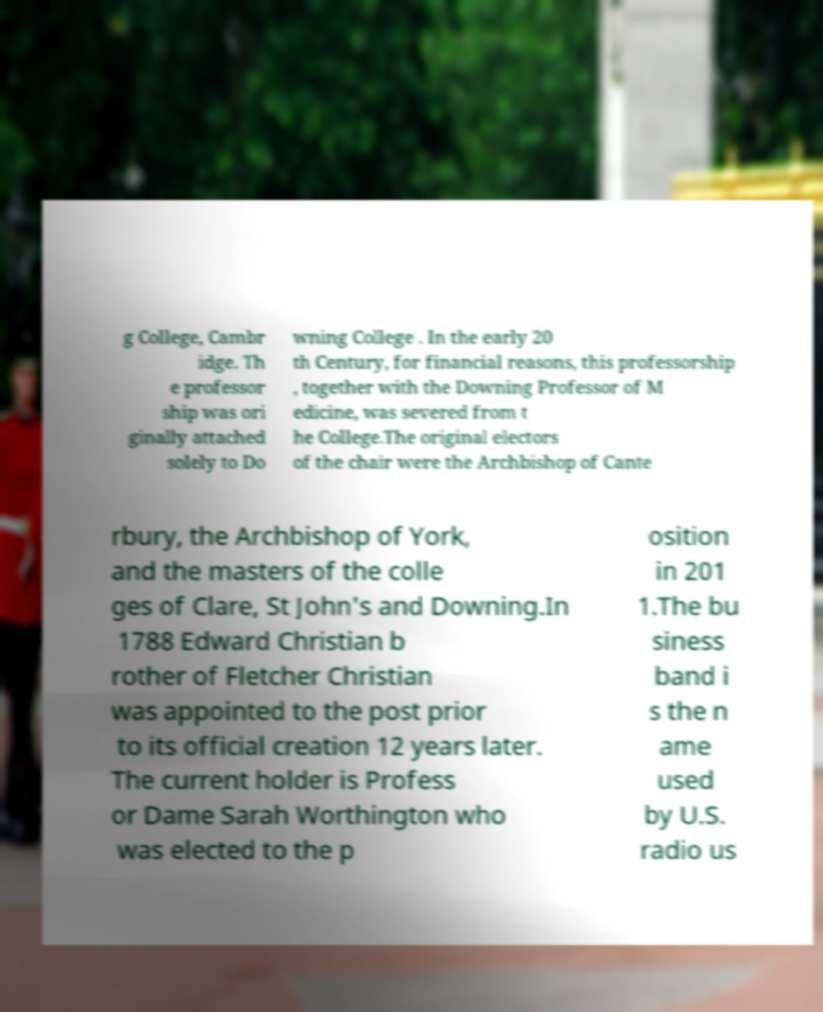Could you extract and type out the text from this image? g College, Cambr idge. Th e professor ship was ori ginally attached solely to Do wning College . In the early 20 th Century, for financial reasons, this professorship , together with the Downing Professor of M edicine, was severed from t he College.The original electors of the chair were the Archbishop of Cante rbury, the Archbishop of York, and the masters of the colle ges of Clare, St John's and Downing.In 1788 Edward Christian b rother of Fletcher Christian was appointed to the post prior to its official creation 12 years later. The current holder is Profess or Dame Sarah Worthington who was elected to the p osition in 201 1.The bu siness band i s the n ame used by U.S. radio us 